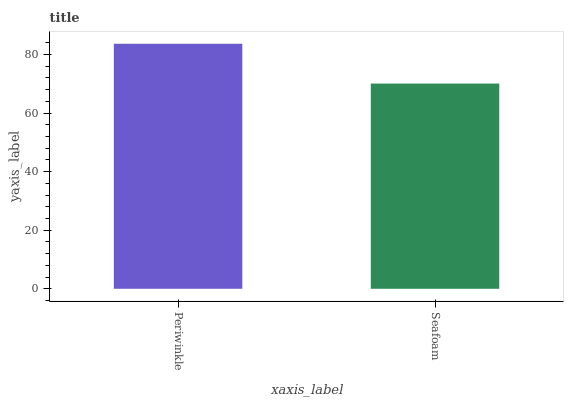Is Seafoam the minimum?
Answer yes or no. Yes. Is Periwinkle the maximum?
Answer yes or no. Yes. Is Seafoam the maximum?
Answer yes or no. No. Is Periwinkle greater than Seafoam?
Answer yes or no. Yes. Is Seafoam less than Periwinkle?
Answer yes or no. Yes. Is Seafoam greater than Periwinkle?
Answer yes or no. No. Is Periwinkle less than Seafoam?
Answer yes or no. No. Is Periwinkle the high median?
Answer yes or no. Yes. Is Seafoam the low median?
Answer yes or no. Yes. Is Seafoam the high median?
Answer yes or no. No. Is Periwinkle the low median?
Answer yes or no. No. 